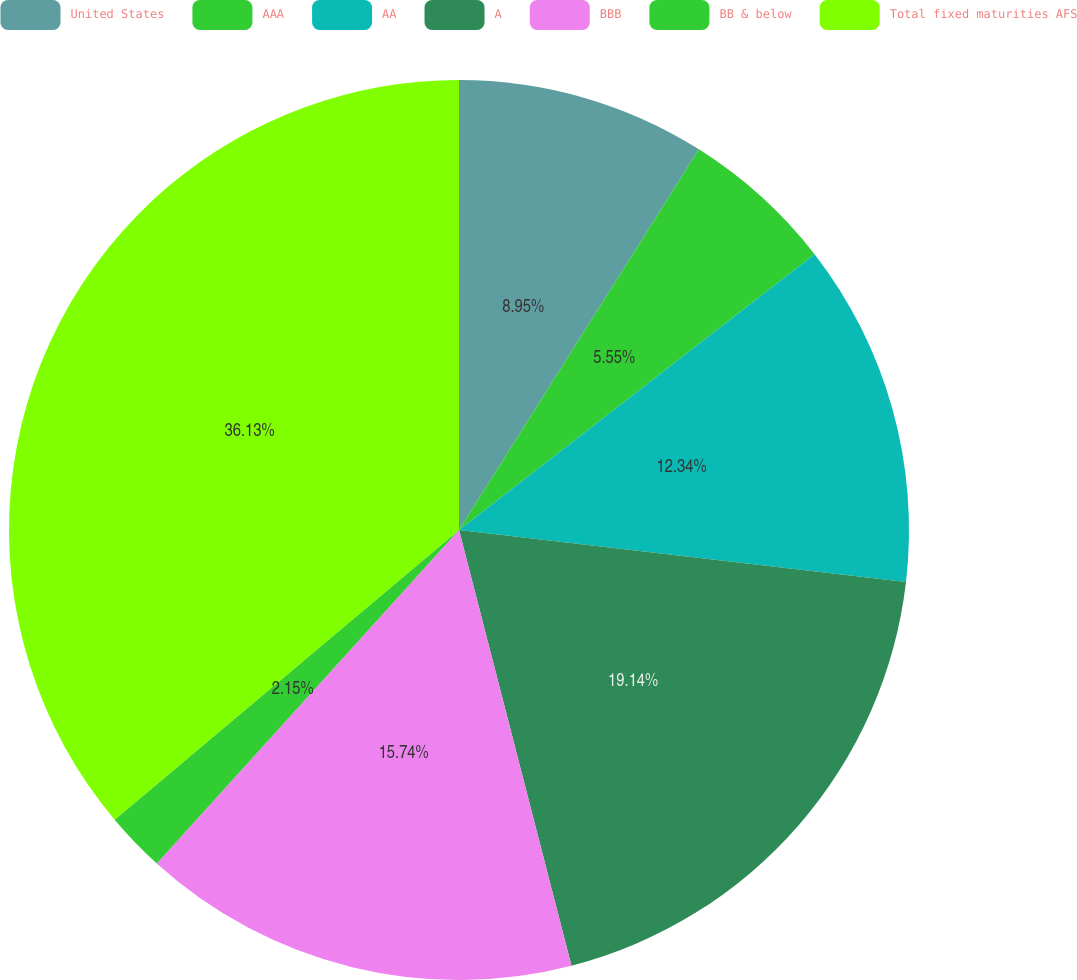<chart> <loc_0><loc_0><loc_500><loc_500><pie_chart><fcel>United States<fcel>AAA<fcel>AA<fcel>A<fcel>BBB<fcel>BB & below<fcel>Total fixed maturities AFS<nl><fcel>8.95%<fcel>5.55%<fcel>12.34%<fcel>19.14%<fcel>15.74%<fcel>2.15%<fcel>36.13%<nl></chart> 